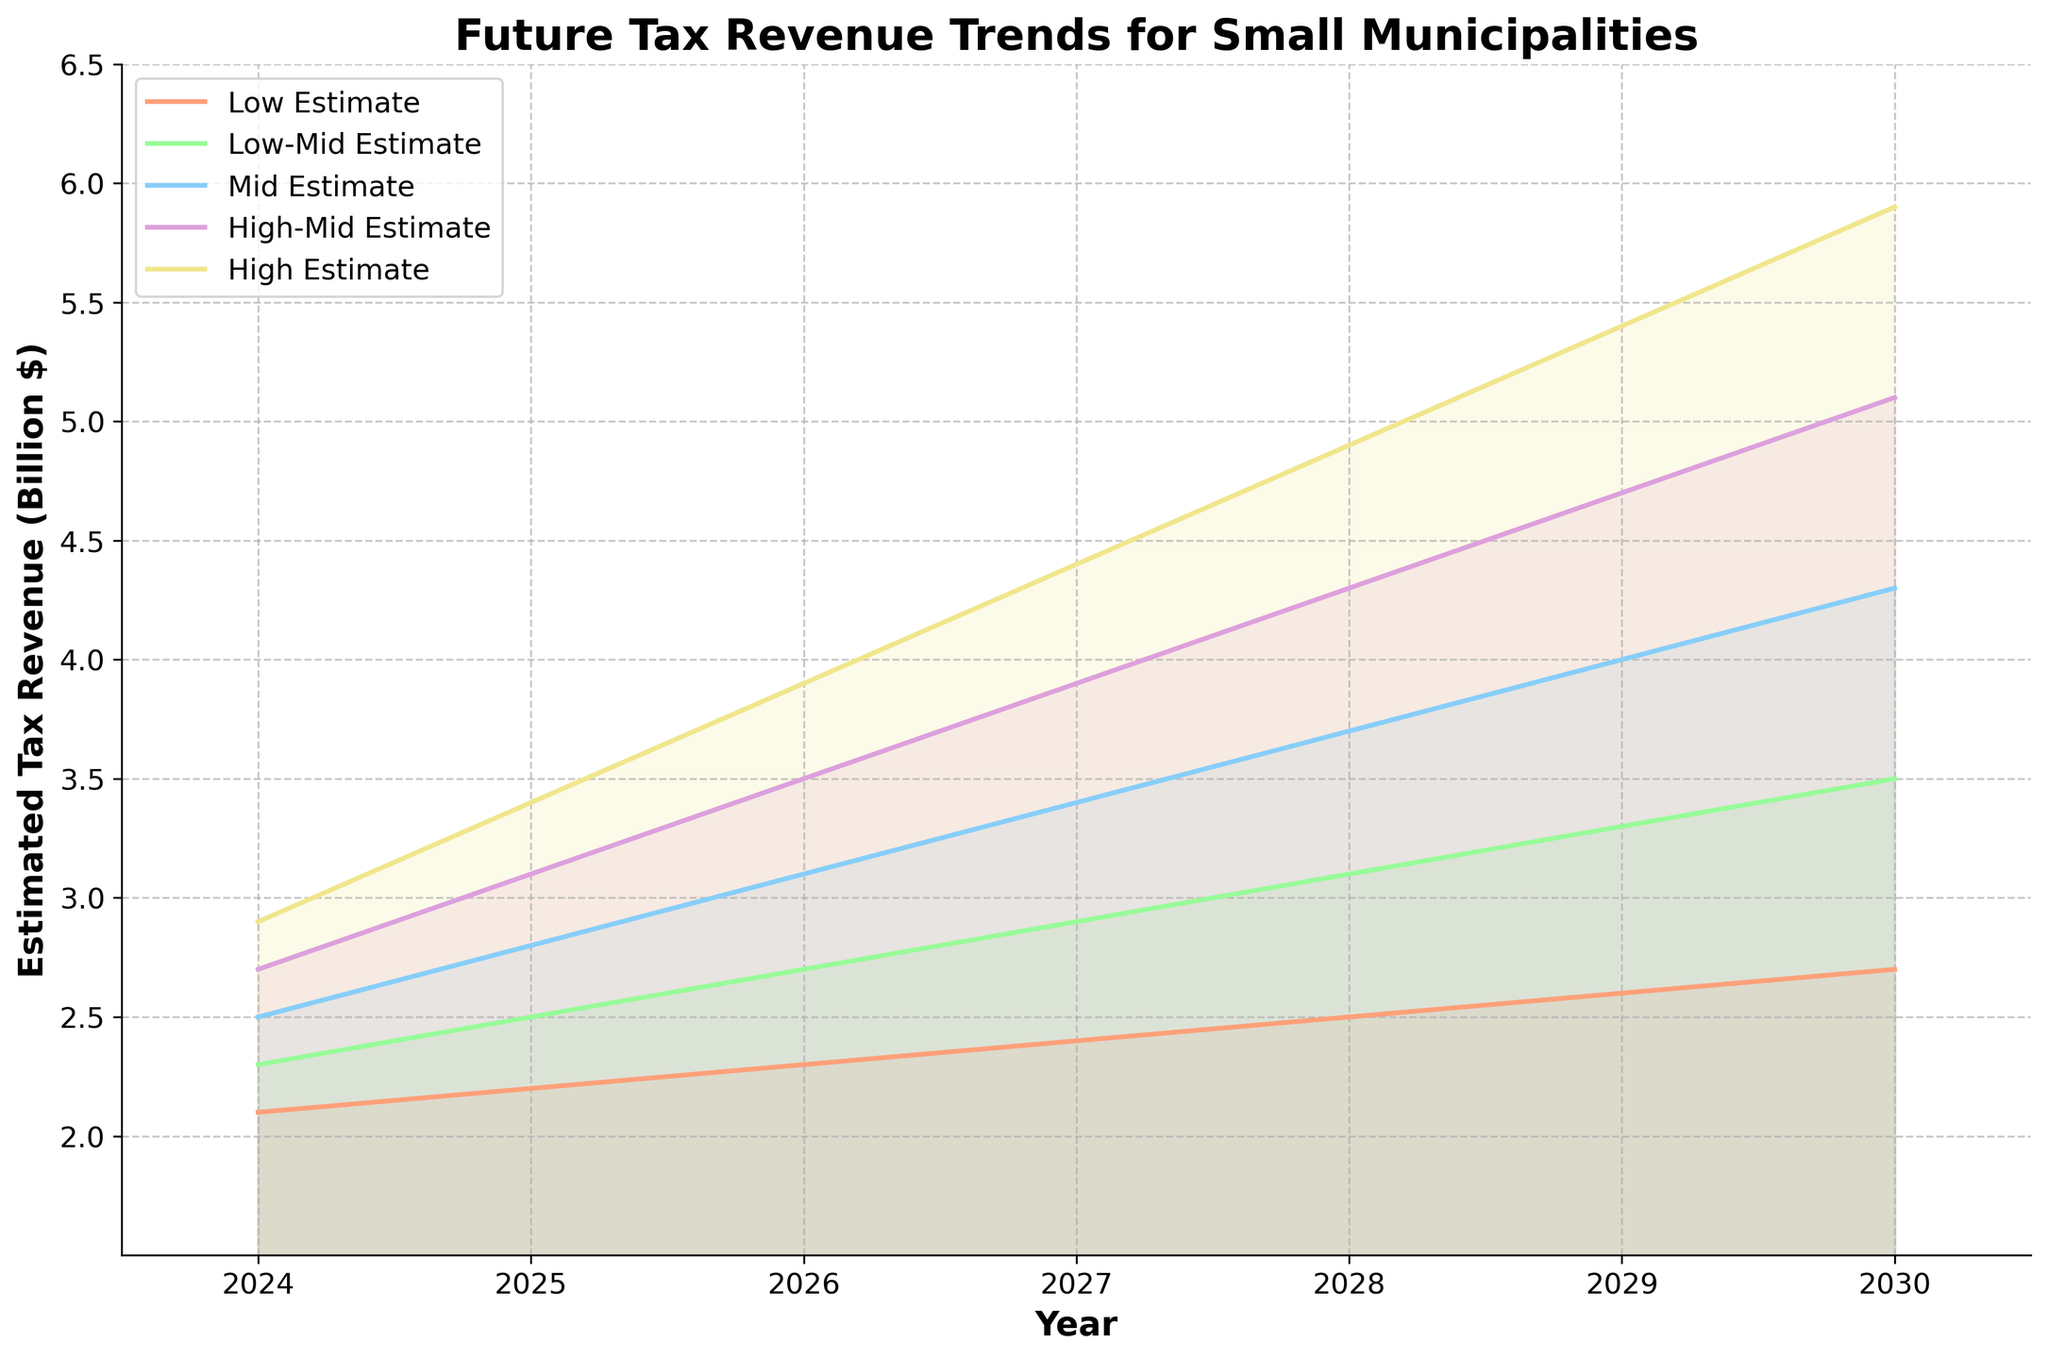Which years are displayed on the x-axis? The x-axis shows the progression in terms of years from 2024 to 2030. These years are listed as data points indicating when the tax revenue estimates are predicted or calculated.
Answer: 2024-2030 What is the estimated midpoint for tax revenue in 2028? The midpoint estimate for tax revenue in 2028 is found in the 'Mid Estimate' column for that year, which is 3.7 billion dollars.
Answer: 3.7 billion dollars Which estimate experiences the highest growth from 2024 to 2030? To find this, compare the differences in estimates from 2024 to 2030. For the 'High Estimate', the values are 2.9 billion dollars in 2024 and 5.9 billion dollars in 2030, showing a growth of 3.0 billion dollars, which is the highest among all estimates.
Answer: High Estimate Is the 'Low Estimate' increasing consistently each year? Reviewing the 'Low Estimate' values from 2024 to 2030 (2.1, 2.2, 2.3, 2.4, 2.5, 2.6, 2.7), we can see that it increases by 0.1 billion dollars each year without any drops, showing a consistent increase.
Answer: Yes What is the range of tax revenue estimates in 2029? The range is calculated by subtracting the 'Low Estimate' from the 'High Estimate' for 2029. This is 5.4 billion dollars (high) minus 2.6 billion dollars (low), resulting in a range of 2.8 billion dollars.
Answer: 2.8 billion dollars Which year shows the smallest difference between the 'Mid Estimate' and 'Low Estimate'? Calculate the differences for each year: 
2024: 2.5 - 2.1 = 0.4 
2025: 2.8 - 2.2 = 0.6 
2026: 3.1 - 2.3 = 0.8 
2027: 3.4 - 2.4 = 1.0 
2028: 3.7 - 2.5 = 1.2 
2029: 4.0 - 2.6 = 1.4 
2030: 4.3 - 2.7 = 1.6. 
The smallest difference is 0.4 in 2024.
Answer: 2024 How much higher is the 'High-Mid Estimate' compared to the 'Low-Mid Estimate' in 2027? Subtracting the 'Low-Mid Estimate' in 2027 (2.9 billion dollars) from the 'High-Mid Estimate' in the same year (3.9 billion dollars) gives a difference of 1.0 billion dollars.
Answer: 1.0 billion dollars In which year does the median of all five estimates exceed 3 billion dollars for the first time? Finding the median for each year:
2024: 2.5 (midpoint);
2025: 2.8 (midpoint);
2026: 3.1 (midpoint);
2027: 3.4 (midpoint);
For the first time in 2026, the midpoint estimate exceeds 3 billion dollars.
Answer: 2026 How does the trend for 'Low-Mid Estimate' change from 2024 to 2030? The 'Low-Mid Estimate' shows an increasing trend each year with values going from 2.3 in 2024 to 3.5 in 2030, which is a steady increase.
Answer: Increasing consistently 